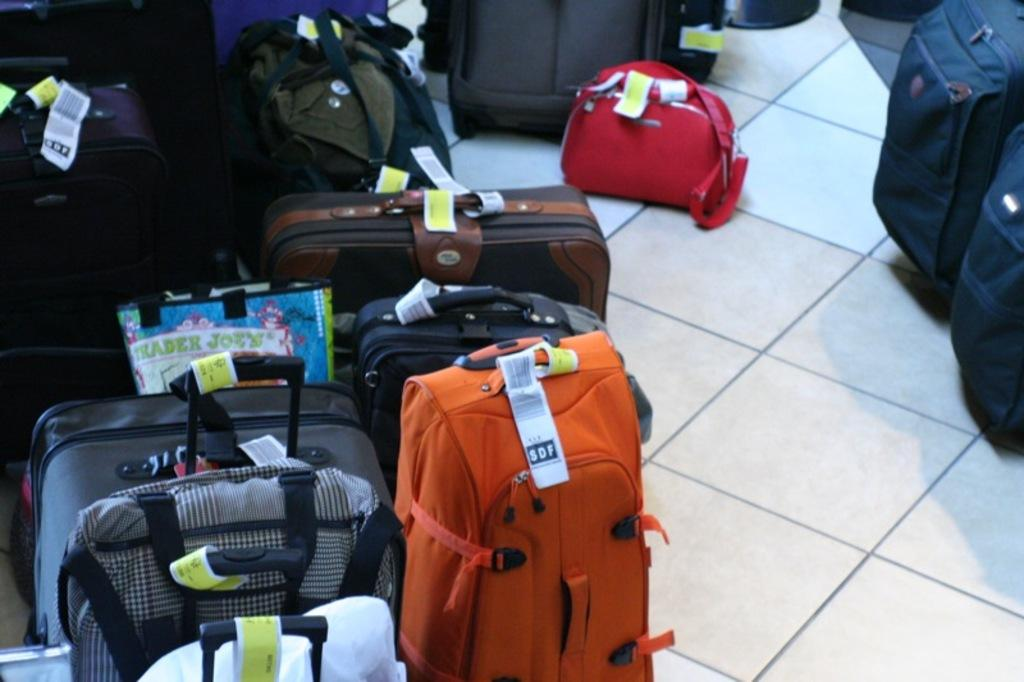What objects are on the floor in the image? There are luggage bags on the floor. What type of trouble can be seen in the jar in the image? There is no jar or trouble present in the image; it only features luggage bags on the floor. 